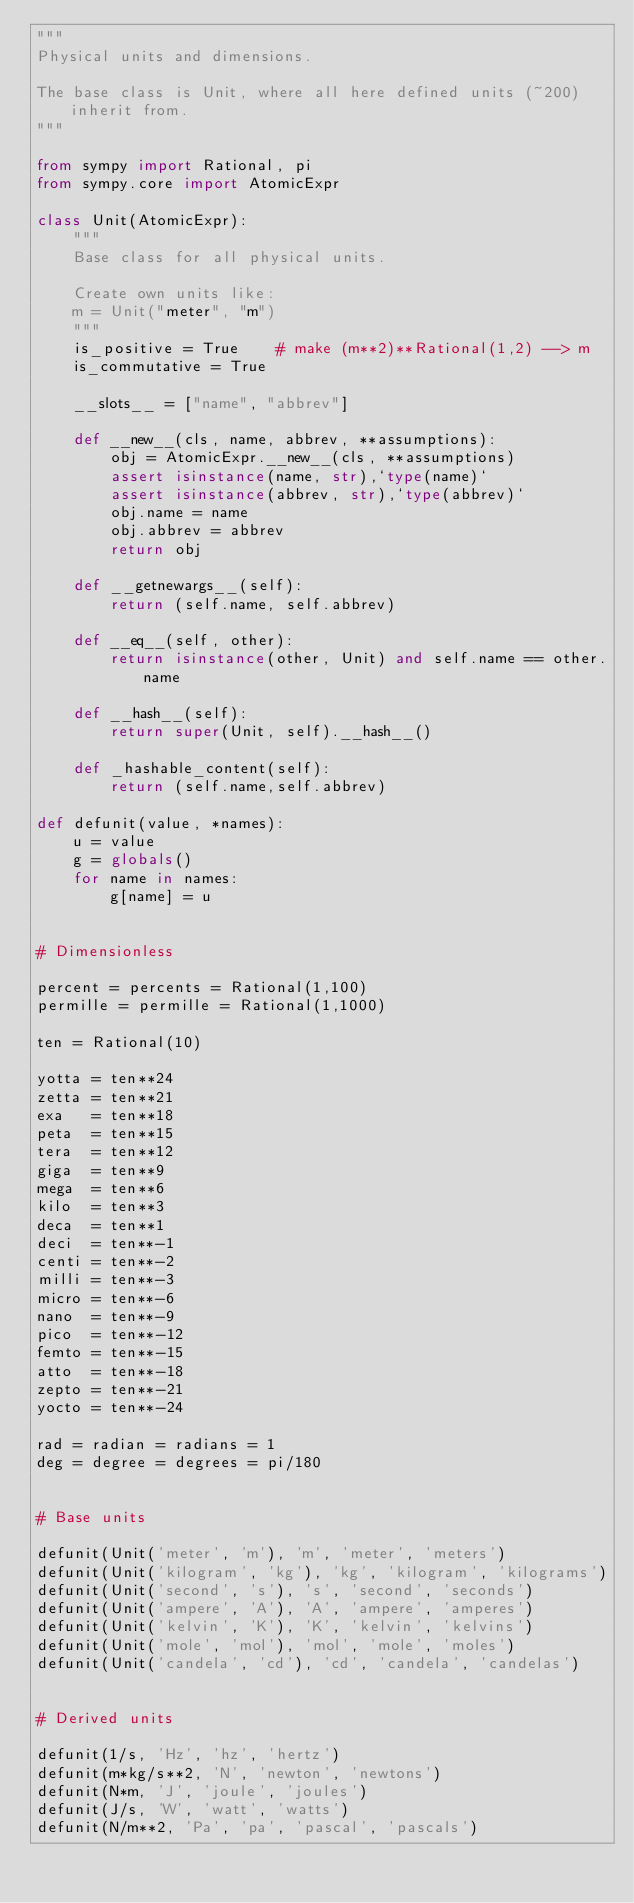Convert code to text. <code><loc_0><loc_0><loc_500><loc_500><_Python_>"""
Physical units and dimensions.

The base class is Unit, where all here defined units (~200) inherit from.
"""

from sympy import Rational, pi
from sympy.core import AtomicExpr

class Unit(AtomicExpr):
    """
    Base class for all physical units.

    Create own units like:
    m = Unit("meter", "m")
    """
    is_positive = True    # make (m**2)**Rational(1,2) --> m
    is_commutative = True

    __slots__ = ["name", "abbrev"]

    def __new__(cls, name, abbrev, **assumptions):
        obj = AtomicExpr.__new__(cls, **assumptions)
        assert isinstance(name, str),`type(name)`
        assert isinstance(abbrev, str),`type(abbrev)`
        obj.name = name
        obj.abbrev = abbrev
        return obj

    def __getnewargs__(self):
        return (self.name, self.abbrev)

    def __eq__(self, other):
        return isinstance(other, Unit) and self.name == other.name

    def __hash__(self):
        return super(Unit, self).__hash__()

    def _hashable_content(self):
        return (self.name,self.abbrev)

def defunit(value, *names):
    u = value
    g = globals()
    for name in names:
        g[name] = u


# Dimensionless

percent = percents = Rational(1,100)
permille = permille = Rational(1,1000)

ten = Rational(10)

yotta = ten**24
zetta = ten**21
exa   = ten**18
peta  = ten**15
tera  = ten**12
giga  = ten**9
mega  = ten**6
kilo  = ten**3
deca  = ten**1
deci  = ten**-1
centi = ten**-2
milli = ten**-3
micro = ten**-6
nano  = ten**-9
pico  = ten**-12
femto = ten**-15
atto  = ten**-18
zepto = ten**-21
yocto = ten**-24

rad = radian = radians = 1
deg = degree = degrees = pi/180


# Base units

defunit(Unit('meter', 'm'), 'm', 'meter', 'meters')
defunit(Unit('kilogram', 'kg'), 'kg', 'kilogram', 'kilograms')
defunit(Unit('second', 's'), 's', 'second', 'seconds')
defunit(Unit('ampere', 'A'), 'A', 'ampere', 'amperes')
defunit(Unit('kelvin', 'K'), 'K', 'kelvin', 'kelvins')
defunit(Unit('mole', 'mol'), 'mol', 'mole', 'moles')
defunit(Unit('candela', 'cd'), 'cd', 'candela', 'candelas')


# Derived units

defunit(1/s, 'Hz', 'hz', 'hertz')
defunit(m*kg/s**2, 'N', 'newton', 'newtons')
defunit(N*m, 'J', 'joule', 'joules')
defunit(J/s, 'W', 'watt', 'watts')
defunit(N/m**2, 'Pa', 'pa', 'pascal', 'pascals')</code> 